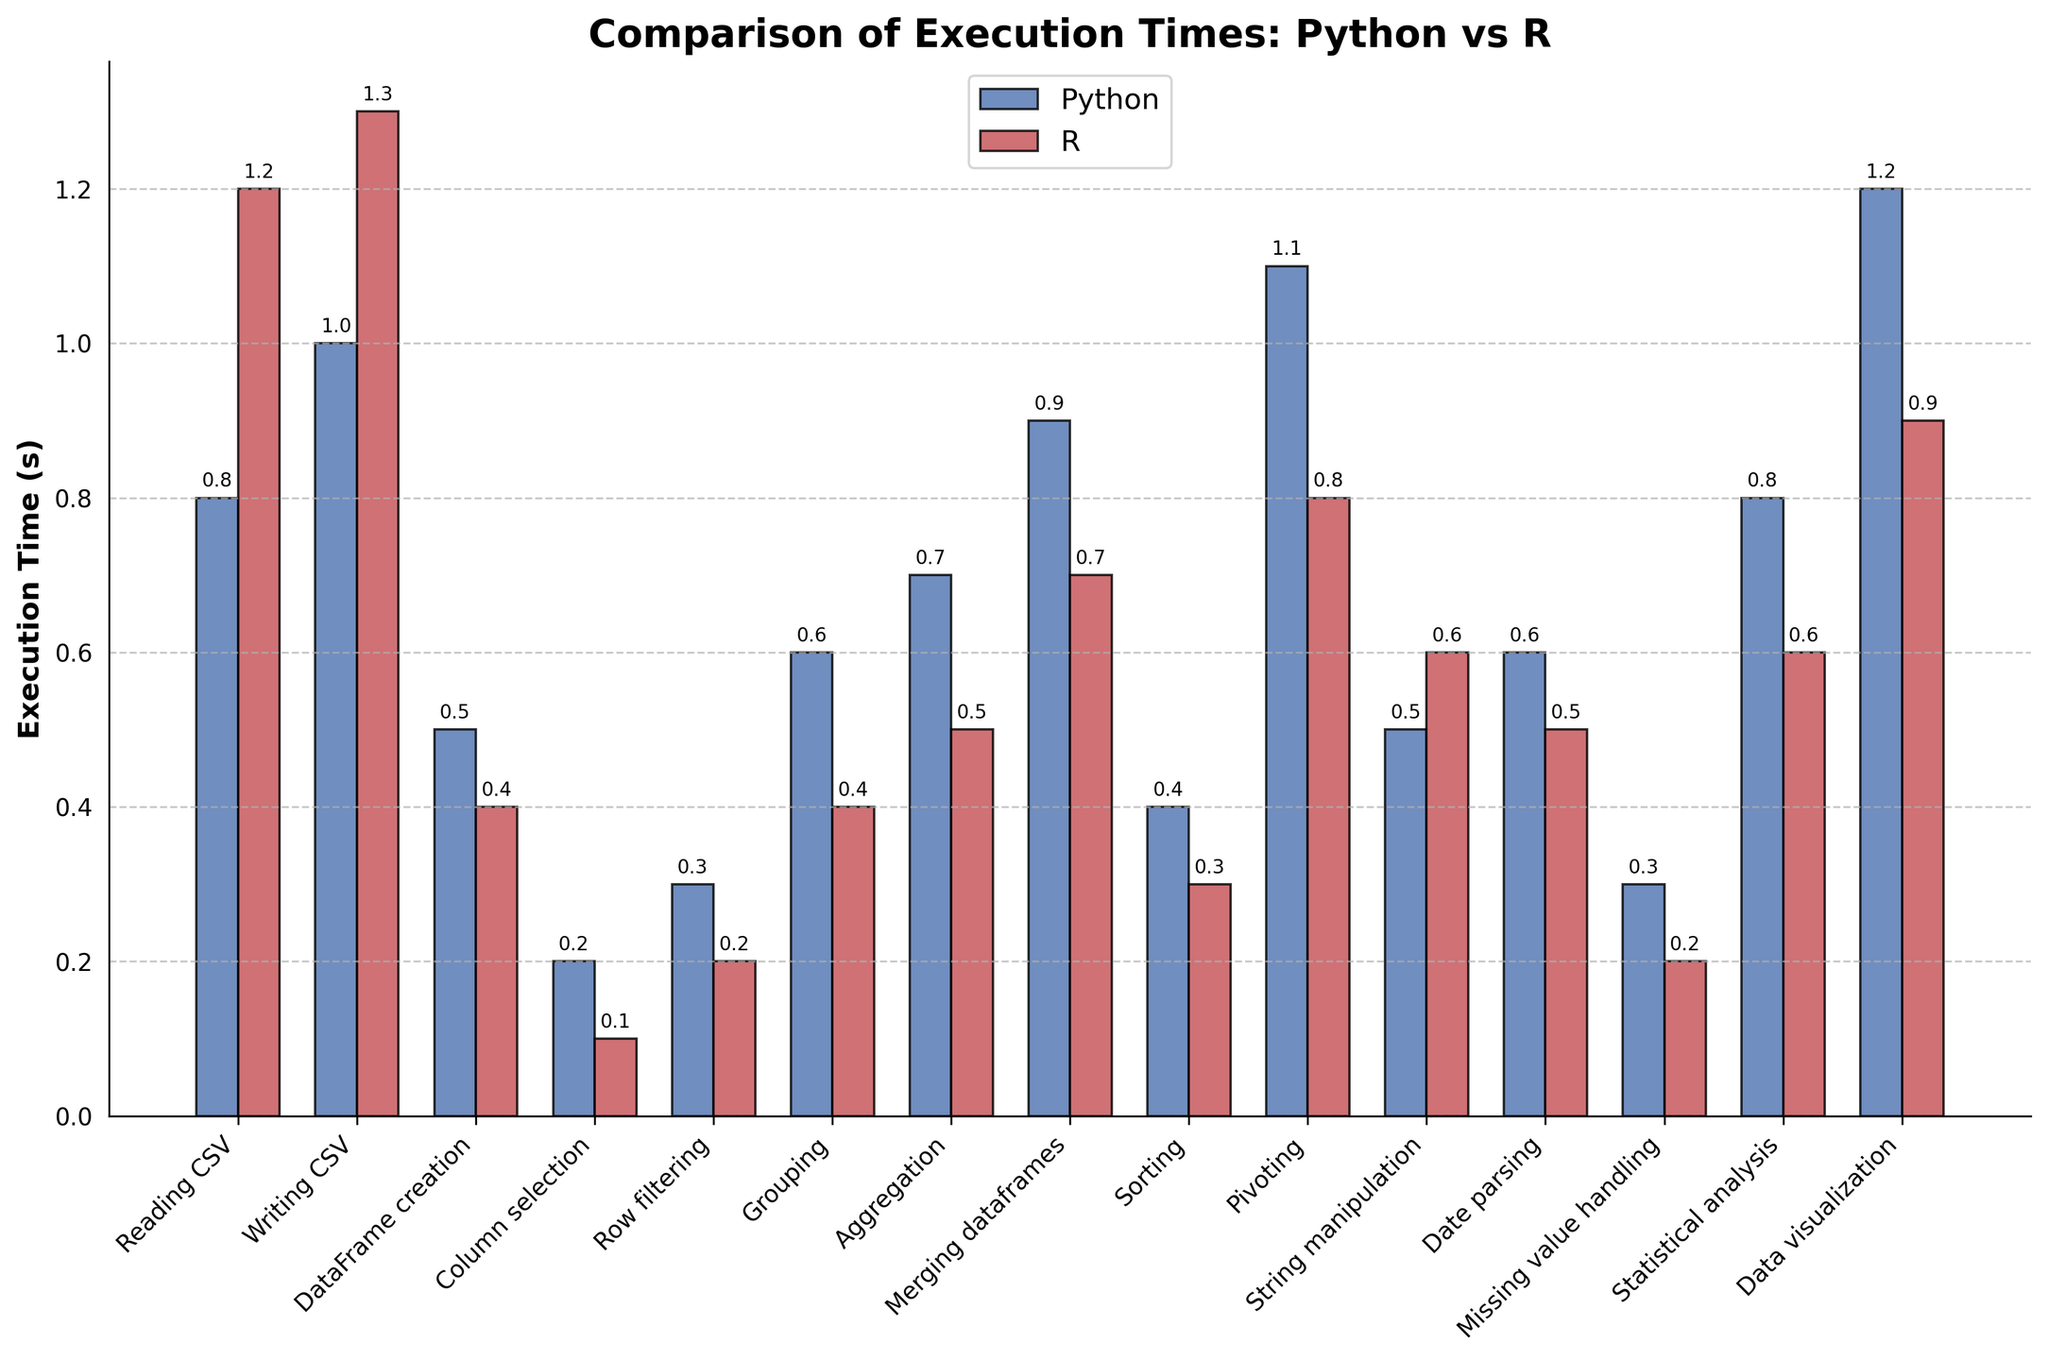Which operation takes the least time in Python as compared to R? The bar heights represent the execution times. For Python, the shortest bar corresponds to the "Column selection" operation.
Answer: Column selection Which operation has the largest difference in execution time between Python and R? Observing the lengths of bars for both Python and R, "Pivoting" shows a significant difference where R is faster than Python.
Answer: Pivoting Compare the execution times of grouping in Python and R. Which is faster and by how much? The bar for "Grouping" in Python is at 0.6 seconds, while the bar for R is at 0.4 seconds. Subtracting these values, R is faster by 0.2 seconds.
Answer: R, by 0.2 seconds What is the average time taken for DataFrame creation in both Python and R? The DataFrame creation times are 0.5 seconds for Python and 0.4 seconds for R. The average is (0.5 + 0.4) / 2 = 0.45 seconds.
Answer: 0.45 seconds How many operations have execution times of 1 second or more in both Python and R? Checking the bar heights, operations like "Reading CSV", "Writing CSV", "Pivoting", and "Data visualization" have bars reaching or exceeding 1 second in Python and/or R.
Answer: 4 Which operations are faster in Python compared to R? Comparing the bar lengths, "DataFrame creation", "Column selection", "Row filtering", "Grouping", "Aggregation", "Merging dataframes", "Sorting", "Pivoting", "Date parsing", "Statistical analysis", and "Data visualization" are those where Python is faster.
Answer: 11 operations What is the total execution time for data manipulation operations (Column selection, Row filtering, Grouping, Aggregation) in Python? Summing execution times: Column selection (0.2) + Row filtering (0.3) + Grouping (0.6) + Aggregation (0.7) equals 1.8 seconds.
Answer: 1.8 seconds Which operation shows the least difference in execution time between Python and R? Observing all bars, "Date parsing" displays a small difference of just 0.1 seconds.
Answer: Date parsing Identify the operation with the highest execution time across both languages. Checking bar heights, "Data visualization" has the tallest bar (1.2 seconds in Python).
Answer: Data visualization For visual inspection, what are the colors used for representing Python and R execution times? The bar for Python times is colored blue, while the bar for R is colored red.
Answer: Blue for Python, Red for R 